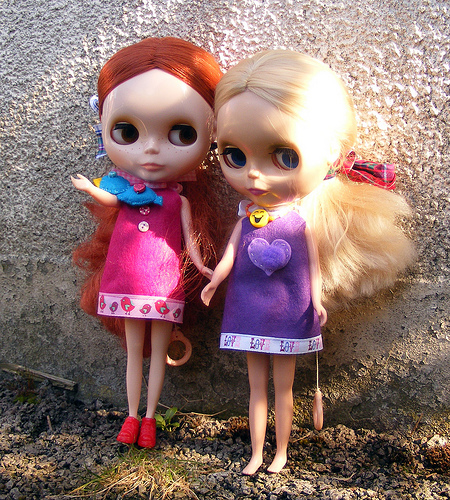<image>
Is the dress on the girl? No. The dress is not positioned on the girl. They may be near each other, but the dress is not supported by or resting on top of the girl. Is the redheaded doll in front of the blonde doll? No. The redheaded doll is not in front of the blonde doll. The spatial positioning shows a different relationship between these objects. 